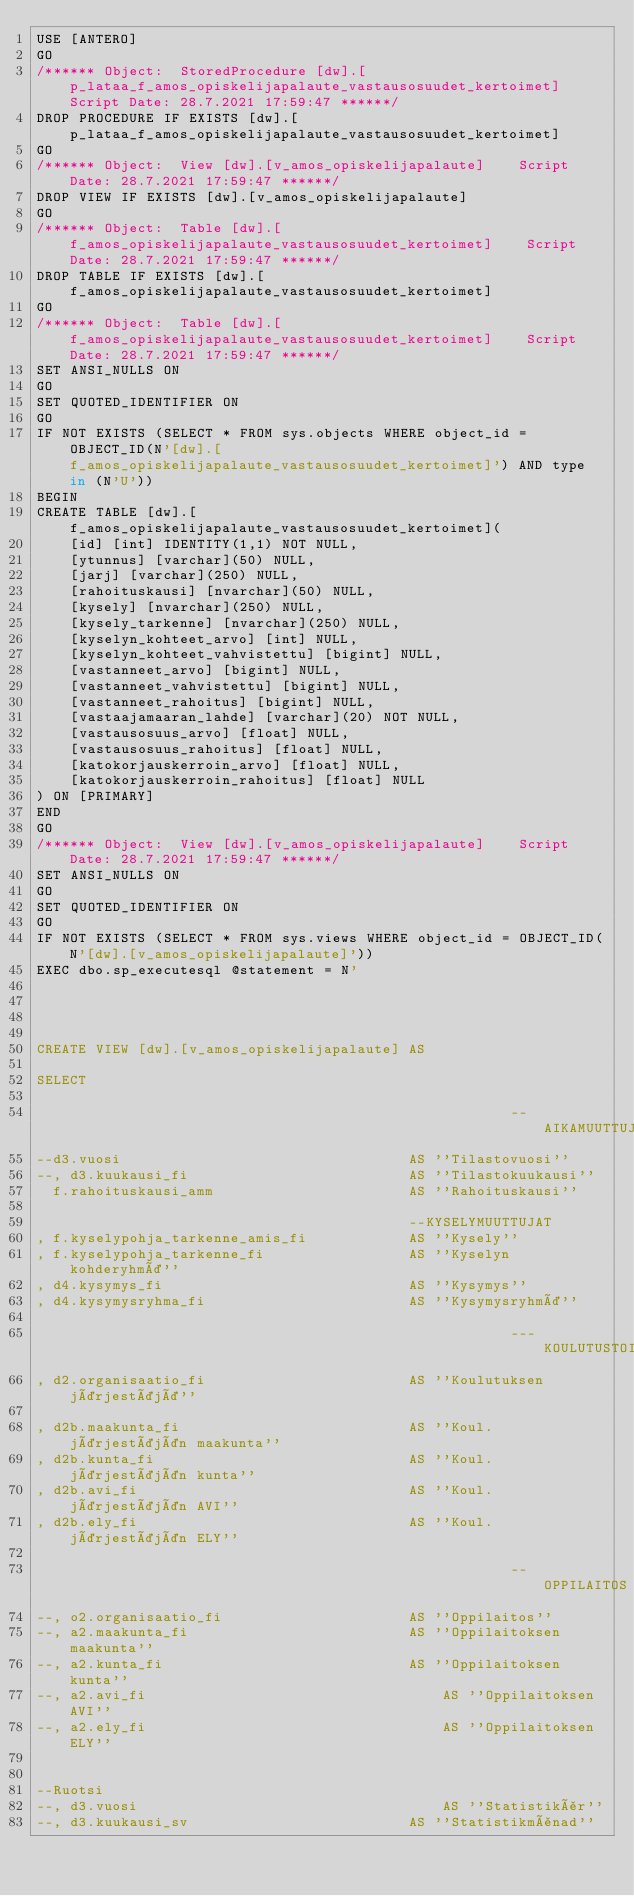<code> <loc_0><loc_0><loc_500><loc_500><_SQL_>USE [ANTERO]
GO
/****** Object:  StoredProcedure [dw].[p_lataa_f_amos_opiskelijapalaute_vastausosuudet_kertoimet]    Script Date: 28.7.2021 17:59:47 ******/
DROP PROCEDURE IF EXISTS [dw].[p_lataa_f_amos_opiskelijapalaute_vastausosuudet_kertoimet]
GO
/****** Object:  View [dw].[v_amos_opiskelijapalaute]    Script Date: 28.7.2021 17:59:47 ******/
DROP VIEW IF EXISTS [dw].[v_amos_opiskelijapalaute]
GO
/****** Object:  Table [dw].[f_amos_opiskelijapalaute_vastausosuudet_kertoimet]    Script Date: 28.7.2021 17:59:47 ******/
DROP TABLE IF EXISTS [dw].[f_amos_opiskelijapalaute_vastausosuudet_kertoimet]
GO
/****** Object:  Table [dw].[f_amos_opiskelijapalaute_vastausosuudet_kertoimet]    Script Date: 28.7.2021 17:59:47 ******/
SET ANSI_NULLS ON
GO
SET QUOTED_IDENTIFIER ON
GO
IF NOT EXISTS (SELECT * FROM sys.objects WHERE object_id = OBJECT_ID(N'[dw].[f_amos_opiskelijapalaute_vastausosuudet_kertoimet]') AND type in (N'U'))
BEGIN
CREATE TABLE [dw].[f_amos_opiskelijapalaute_vastausosuudet_kertoimet](
	[id] [int] IDENTITY(1,1) NOT NULL,
	[ytunnus] [varchar](50) NULL,
	[jarj] [varchar](250) NULL,
	[rahoituskausi] [nvarchar](50) NULL,
	[kysely] [nvarchar](250) NULL,
	[kysely_tarkenne] [nvarchar](250) NULL,
	[kyselyn_kohteet_arvo] [int] NULL,
	[kyselyn_kohteet_vahvistettu] [bigint] NULL,
	[vastanneet_arvo] [bigint] NULL,
	[vastanneet_vahvistettu] [bigint] NULL,
	[vastanneet_rahoitus] [bigint] NULL,
	[vastaajamaaran_lahde] [varchar](20) NOT NULL,
	[vastausosuus_arvo] [float] NULL,
	[vastausosuus_rahoitus] [float] NULL,
	[katokorjauskerroin_arvo] [float] NULL,
	[katokorjauskerroin_rahoitus] [float] NULL
) ON [PRIMARY]
END
GO
/****** Object:  View [dw].[v_amos_opiskelijapalaute]    Script Date: 28.7.2021 17:59:47 ******/
SET ANSI_NULLS ON
GO
SET QUOTED_IDENTIFIER ON
GO
IF NOT EXISTS (SELECT * FROM sys.views WHERE object_id = OBJECT_ID(N'[dw].[v_amos_opiskelijapalaute]'))
EXEC dbo.sp_executesql @statement = N'




CREATE VIEW [dw].[v_amos_opiskelijapalaute] AS

SELECT 

														--AIKAMUUTTUJAT
--d3.vuosi									AS ''Tilastovuosi''
--, d3.kuukausi_fi							AS ''Tilastokuukausi''
  f.rahoituskausi_amm						AS ''Rahoituskausi''
											
											--KYSELYMUUTTUJAT
, f.kyselypohja_tarkenne_amis_fi			AS ''Kysely''
, f.kyselypohja_tarkenne_fi					AS ''Kyselyn kohderyhmä''  
, d4.kysymys_fi								AS ''Kysymys''
, d4.kysymysryhma_fi						AS ''Kysymysryhmä''

														---KOULUTUSTOIMIJA
, d2.organisaatio_fi						AS ''Koulutuksen järjestäjä''

, d2b.maakunta_fi							AS ''Koul. järjestäjän maakunta''
, d2b.kunta_fi								AS ''Koul. järjestäjän kunta''
, d2b.avi_fi								AS ''Koul. järjestäjän AVI''
, d2b.ely_fi								AS ''Koul. järjestäjän ELY''

														--OPPILAITOS
--, o2.organisaatio_fi						AS ''Oppilaitos''
--, a2.maakunta_fi							AS ''Oppilaitoksen maakunta''
--, a2.kunta_fi								AS ''Oppilaitoksen kunta''
--, a2.avi_fi									AS ''Oppilaitoksen AVI''
--, a2.ely_fi									AS ''Oppilaitoksen ELY''


--Ruotsi
--, d3.vuosi									AS ''Statistikår''
--, d3.kuukausi_sv							AS ''Statistikmånad''</code> 